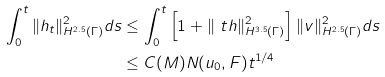Convert formula to latex. <formula><loc_0><loc_0><loc_500><loc_500>\int _ { 0 } ^ { t } \| h _ { t } \| ^ { 2 } _ { H ^ { 2 . 5 } ( \Gamma ) } d s & \leq \int _ { 0 } ^ { t } \left [ 1 + \| \ t h \| ^ { 2 } _ { H ^ { 3 . 5 } ( \Gamma ) } \right ] \| v \| ^ { 2 } _ { H ^ { 2 . 5 } ( \Gamma ) } d s \\ & \leq C ( M ) N ( u _ { 0 } , F ) t ^ { 1 / 4 }</formula> 